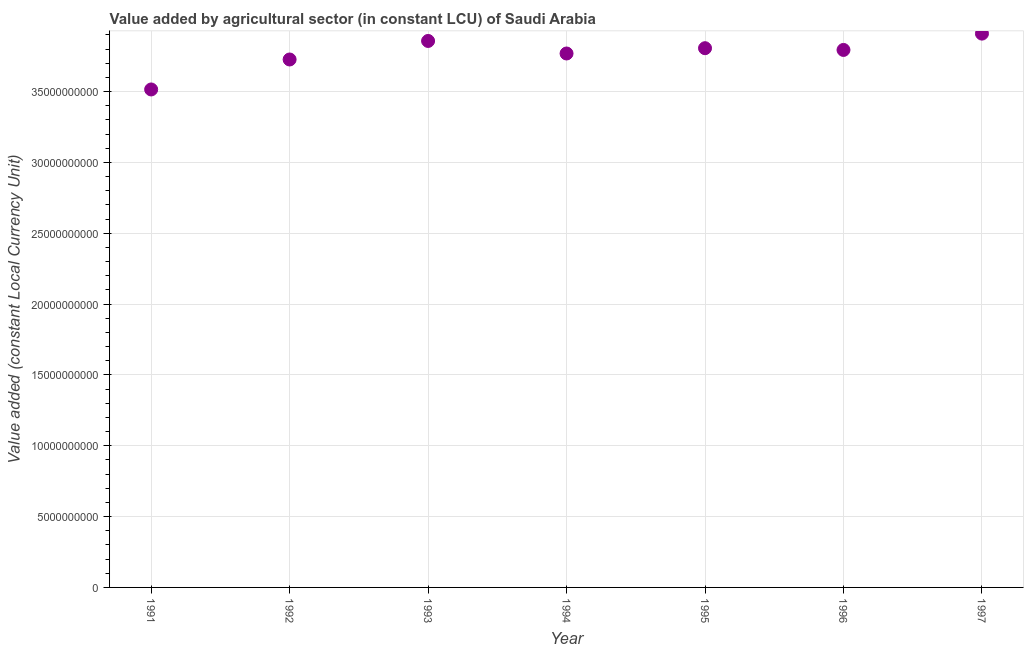What is the value added by agriculture sector in 1994?
Ensure brevity in your answer.  3.77e+1. Across all years, what is the maximum value added by agriculture sector?
Offer a terse response. 3.91e+1. Across all years, what is the minimum value added by agriculture sector?
Provide a succinct answer. 3.51e+1. In which year was the value added by agriculture sector maximum?
Provide a short and direct response. 1997. What is the sum of the value added by agriculture sector?
Ensure brevity in your answer.  2.64e+11. What is the difference between the value added by agriculture sector in 1992 and 1994?
Ensure brevity in your answer.  -4.23e+08. What is the average value added by agriculture sector per year?
Provide a succinct answer. 3.77e+1. What is the median value added by agriculture sector?
Keep it short and to the point. 3.79e+1. Do a majority of the years between 1991 and 1993 (inclusive) have value added by agriculture sector greater than 34000000000 LCU?
Keep it short and to the point. Yes. What is the ratio of the value added by agriculture sector in 1996 to that in 1997?
Ensure brevity in your answer.  0.97. Is the value added by agriculture sector in 1993 less than that in 1995?
Your answer should be very brief. No. Is the difference between the value added by agriculture sector in 1995 and 1996 greater than the difference between any two years?
Give a very brief answer. No. What is the difference between the highest and the second highest value added by agriculture sector?
Your response must be concise. 5.18e+08. What is the difference between the highest and the lowest value added by agriculture sector?
Offer a very short reply. 3.94e+09. In how many years, is the value added by agriculture sector greater than the average value added by agriculture sector taken over all years?
Keep it short and to the point. 5. Does the value added by agriculture sector monotonically increase over the years?
Your answer should be compact. No. How many years are there in the graph?
Your response must be concise. 7. Are the values on the major ticks of Y-axis written in scientific E-notation?
Give a very brief answer. No. What is the title of the graph?
Ensure brevity in your answer.  Value added by agricultural sector (in constant LCU) of Saudi Arabia. What is the label or title of the Y-axis?
Give a very brief answer. Value added (constant Local Currency Unit). What is the Value added (constant Local Currency Unit) in 1991?
Keep it short and to the point. 3.51e+1. What is the Value added (constant Local Currency Unit) in 1992?
Give a very brief answer. 3.73e+1. What is the Value added (constant Local Currency Unit) in 1993?
Ensure brevity in your answer.  3.86e+1. What is the Value added (constant Local Currency Unit) in 1994?
Your response must be concise. 3.77e+1. What is the Value added (constant Local Currency Unit) in 1995?
Your answer should be very brief. 3.81e+1. What is the Value added (constant Local Currency Unit) in 1996?
Ensure brevity in your answer.  3.79e+1. What is the Value added (constant Local Currency Unit) in 1997?
Provide a succinct answer. 3.91e+1. What is the difference between the Value added (constant Local Currency Unit) in 1991 and 1992?
Offer a terse response. -2.12e+09. What is the difference between the Value added (constant Local Currency Unit) in 1991 and 1993?
Keep it short and to the point. -3.42e+09. What is the difference between the Value added (constant Local Currency Unit) in 1991 and 1994?
Make the answer very short. -2.54e+09. What is the difference between the Value added (constant Local Currency Unit) in 1991 and 1995?
Your answer should be compact. -2.91e+09. What is the difference between the Value added (constant Local Currency Unit) in 1991 and 1996?
Provide a short and direct response. -2.79e+09. What is the difference between the Value added (constant Local Currency Unit) in 1991 and 1997?
Your response must be concise. -3.94e+09. What is the difference between the Value added (constant Local Currency Unit) in 1992 and 1993?
Provide a succinct answer. -1.31e+09. What is the difference between the Value added (constant Local Currency Unit) in 1992 and 1994?
Ensure brevity in your answer.  -4.23e+08. What is the difference between the Value added (constant Local Currency Unit) in 1992 and 1995?
Ensure brevity in your answer.  -7.97e+08. What is the difference between the Value added (constant Local Currency Unit) in 1992 and 1996?
Provide a short and direct response. -6.74e+08. What is the difference between the Value added (constant Local Currency Unit) in 1992 and 1997?
Provide a succinct answer. -1.83e+09. What is the difference between the Value added (constant Local Currency Unit) in 1993 and 1994?
Ensure brevity in your answer.  8.85e+08. What is the difference between the Value added (constant Local Currency Unit) in 1993 and 1995?
Give a very brief answer. 5.11e+08. What is the difference between the Value added (constant Local Currency Unit) in 1993 and 1996?
Offer a terse response. 6.34e+08. What is the difference between the Value added (constant Local Currency Unit) in 1993 and 1997?
Give a very brief answer. -5.18e+08. What is the difference between the Value added (constant Local Currency Unit) in 1994 and 1995?
Give a very brief answer. -3.74e+08. What is the difference between the Value added (constant Local Currency Unit) in 1994 and 1996?
Provide a succinct answer. -2.51e+08. What is the difference between the Value added (constant Local Currency Unit) in 1994 and 1997?
Provide a succinct answer. -1.40e+09. What is the difference between the Value added (constant Local Currency Unit) in 1995 and 1996?
Keep it short and to the point. 1.23e+08. What is the difference between the Value added (constant Local Currency Unit) in 1995 and 1997?
Keep it short and to the point. -1.03e+09. What is the difference between the Value added (constant Local Currency Unit) in 1996 and 1997?
Keep it short and to the point. -1.15e+09. What is the ratio of the Value added (constant Local Currency Unit) in 1991 to that in 1992?
Your answer should be very brief. 0.94. What is the ratio of the Value added (constant Local Currency Unit) in 1991 to that in 1993?
Keep it short and to the point. 0.91. What is the ratio of the Value added (constant Local Currency Unit) in 1991 to that in 1994?
Provide a short and direct response. 0.93. What is the ratio of the Value added (constant Local Currency Unit) in 1991 to that in 1995?
Keep it short and to the point. 0.92. What is the ratio of the Value added (constant Local Currency Unit) in 1991 to that in 1996?
Give a very brief answer. 0.93. What is the ratio of the Value added (constant Local Currency Unit) in 1991 to that in 1997?
Ensure brevity in your answer.  0.9. What is the ratio of the Value added (constant Local Currency Unit) in 1992 to that in 1993?
Provide a succinct answer. 0.97. What is the ratio of the Value added (constant Local Currency Unit) in 1992 to that in 1997?
Provide a short and direct response. 0.95. What is the ratio of the Value added (constant Local Currency Unit) in 1993 to that in 1996?
Provide a short and direct response. 1.02. What is the ratio of the Value added (constant Local Currency Unit) in 1994 to that in 1997?
Your answer should be compact. 0.96. What is the ratio of the Value added (constant Local Currency Unit) in 1995 to that in 1996?
Your response must be concise. 1. What is the ratio of the Value added (constant Local Currency Unit) in 1996 to that in 1997?
Provide a succinct answer. 0.97. 